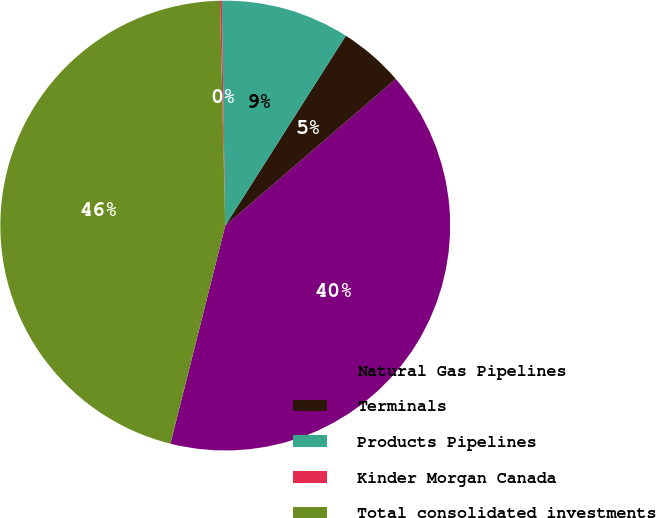Convert chart to OTSL. <chart><loc_0><loc_0><loc_500><loc_500><pie_chart><fcel>Natural Gas Pipelines<fcel>Terminals<fcel>Products Pipelines<fcel>Kinder Morgan Canada<fcel>Total consolidated investments<nl><fcel>40.23%<fcel>4.69%<fcel>9.25%<fcel>0.13%<fcel>45.71%<nl></chart> 